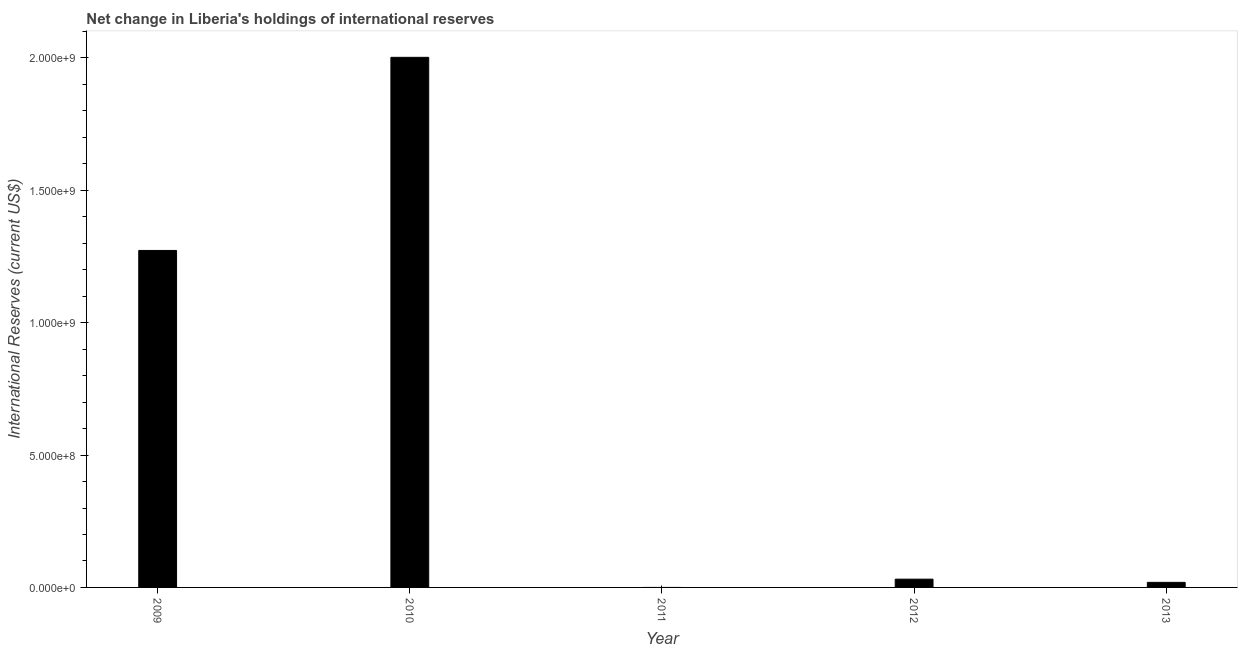Does the graph contain any zero values?
Give a very brief answer. Yes. What is the title of the graph?
Offer a terse response. Net change in Liberia's holdings of international reserves. What is the label or title of the X-axis?
Your response must be concise. Year. What is the label or title of the Y-axis?
Ensure brevity in your answer.  International Reserves (current US$). Across all years, what is the maximum reserves and related items?
Provide a short and direct response. 2.00e+09. In which year was the reserves and related items maximum?
Offer a very short reply. 2010. What is the sum of the reserves and related items?
Make the answer very short. 3.33e+09. What is the difference between the reserves and related items in 2009 and 2010?
Provide a succinct answer. -7.30e+08. What is the average reserves and related items per year?
Your answer should be very brief. 6.65e+08. What is the median reserves and related items?
Your response must be concise. 3.12e+07. In how many years, is the reserves and related items greater than 200000000 US$?
Offer a terse response. 2. What is the difference between the highest and the second highest reserves and related items?
Your answer should be compact. 7.30e+08. Is the sum of the reserves and related items in 2010 and 2012 greater than the maximum reserves and related items across all years?
Your answer should be compact. Yes. What is the difference between the highest and the lowest reserves and related items?
Make the answer very short. 2.00e+09. What is the difference between two consecutive major ticks on the Y-axis?
Offer a terse response. 5.00e+08. What is the International Reserves (current US$) of 2009?
Provide a short and direct response. 1.27e+09. What is the International Reserves (current US$) in 2010?
Make the answer very short. 2.00e+09. What is the International Reserves (current US$) in 2012?
Offer a very short reply. 3.12e+07. What is the International Reserves (current US$) of 2013?
Make the answer very short. 1.91e+07. What is the difference between the International Reserves (current US$) in 2009 and 2010?
Your answer should be compact. -7.30e+08. What is the difference between the International Reserves (current US$) in 2009 and 2012?
Make the answer very short. 1.24e+09. What is the difference between the International Reserves (current US$) in 2009 and 2013?
Offer a very short reply. 1.25e+09. What is the difference between the International Reserves (current US$) in 2010 and 2012?
Your answer should be compact. 1.97e+09. What is the difference between the International Reserves (current US$) in 2010 and 2013?
Offer a terse response. 1.98e+09. What is the difference between the International Reserves (current US$) in 2012 and 2013?
Provide a succinct answer. 1.21e+07. What is the ratio of the International Reserves (current US$) in 2009 to that in 2010?
Keep it short and to the point. 0.64. What is the ratio of the International Reserves (current US$) in 2009 to that in 2012?
Provide a short and direct response. 40.75. What is the ratio of the International Reserves (current US$) in 2009 to that in 2013?
Make the answer very short. 66.65. What is the ratio of the International Reserves (current US$) in 2010 to that in 2012?
Ensure brevity in your answer.  64.1. What is the ratio of the International Reserves (current US$) in 2010 to that in 2013?
Give a very brief answer. 104.84. What is the ratio of the International Reserves (current US$) in 2012 to that in 2013?
Keep it short and to the point. 1.64. 